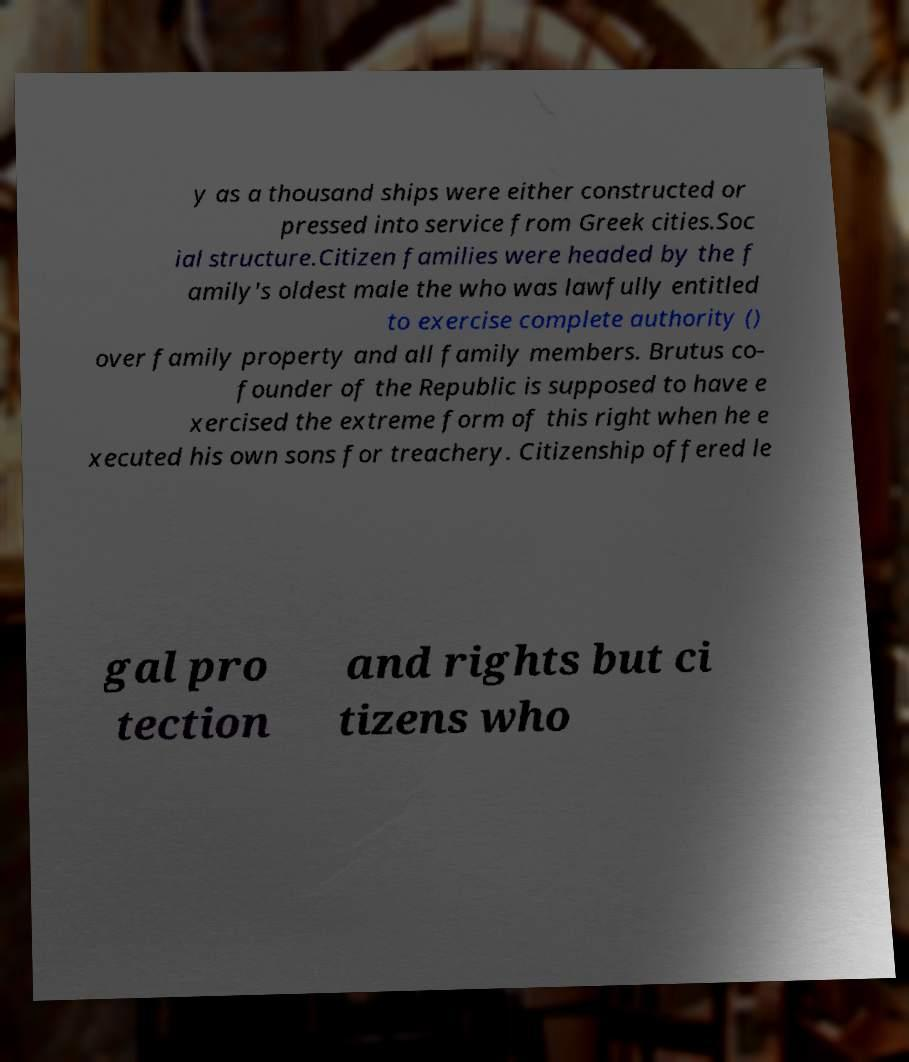Could you extract and type out the text from this image? y as a thousand ships were either constructed or pressed into service from Greek cities.Soc ial structure.Citizen families were headed by the f amily's oldest male the who was lawfully entitled to exercise complete authority () over family property and all family members. Brutus co- founder of the Republic is supposed to have e xercised the extreme form of this right when he e xecuted his own sons for treachery. Citizenship offered le gal pro tection and rights but ci tizens who 